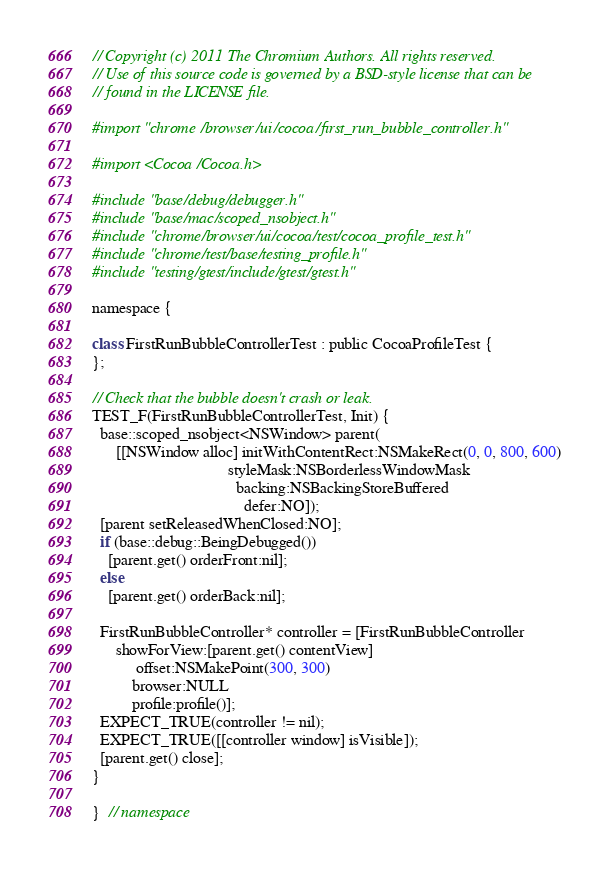<code> <loc_0><loc_0><loc_500><loc_500><_ObjectiveC_>// Copyright (c) 2011 The Chromium Authors. All rights reserved.
// Use of this source code is governed by a BSD-style license that can be
// found in the LICENSE file.

#import "chrome/browser/ui/cocoa/first_run_bubble_controller.h"

#import <Cocoa/Cocoa.h>

#include "base/debug/debugger.h"
#include "base/mac/scoped_nsobject.h"
#include "chrome/browser/ui/cocoa/test/cocoa_profile_test.h"
#include "chrome/test/base/testing_profile.h"
#include "testing/gtest/include/gtest/gtest.h"

namespace {

class FirstRunBubbleControllerTest : public CocoaProfileTest {
};

// Check that the bubble doesn't crash or leak.
TEST_F(FirstRunBubbleControllerTest, Init) {
  base::scoped_nsobject<NSWindow> parent(
      [[NSWindow alloc] initWithContentRect:NSMakeRect(0, 0, 800, 600)
                                  styleMask:NSBorderlessWindowMask
                                    backing:NSBackingStoreBuffered
                                      defer:NO]);
  [parent setReleasedWhenClosed:NO];
  if (base::debug::BeingDebugged())
    [parent.get() orderFront:nil];
  else
    [parent.get() orderBack:nil];

  FirstRunBubbleController* controller = [FirstRunBubbleController
      showForView:[parent.get() contentView]
           offset:NSMakePoint(300, 300)
          browser:NULL
          profile:profile()];
  EXPECT_TRUE(controller != nil);
  EXPECT_TRUE([[controller window] isVisible]);
  [parent.get() close];
}

}  // namespace
</code> 